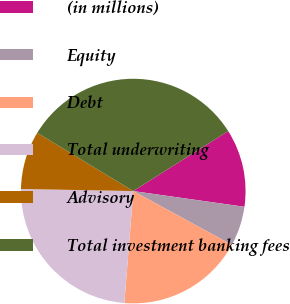<chart> <loc_0><loc_0><loc_500><loc_500><pie_chart><fcel>(in millions)<fcel>Equity<fcel>Debt<fcel>Total underwriting<fcel>Advisory<fcel>Total investment banking fees<nl><fcel>11.21%<fcel>5.71%<fcel>18.32%<fcel>24.04%<fcel>8.38%<fcel>32.35%<nl></chart> 